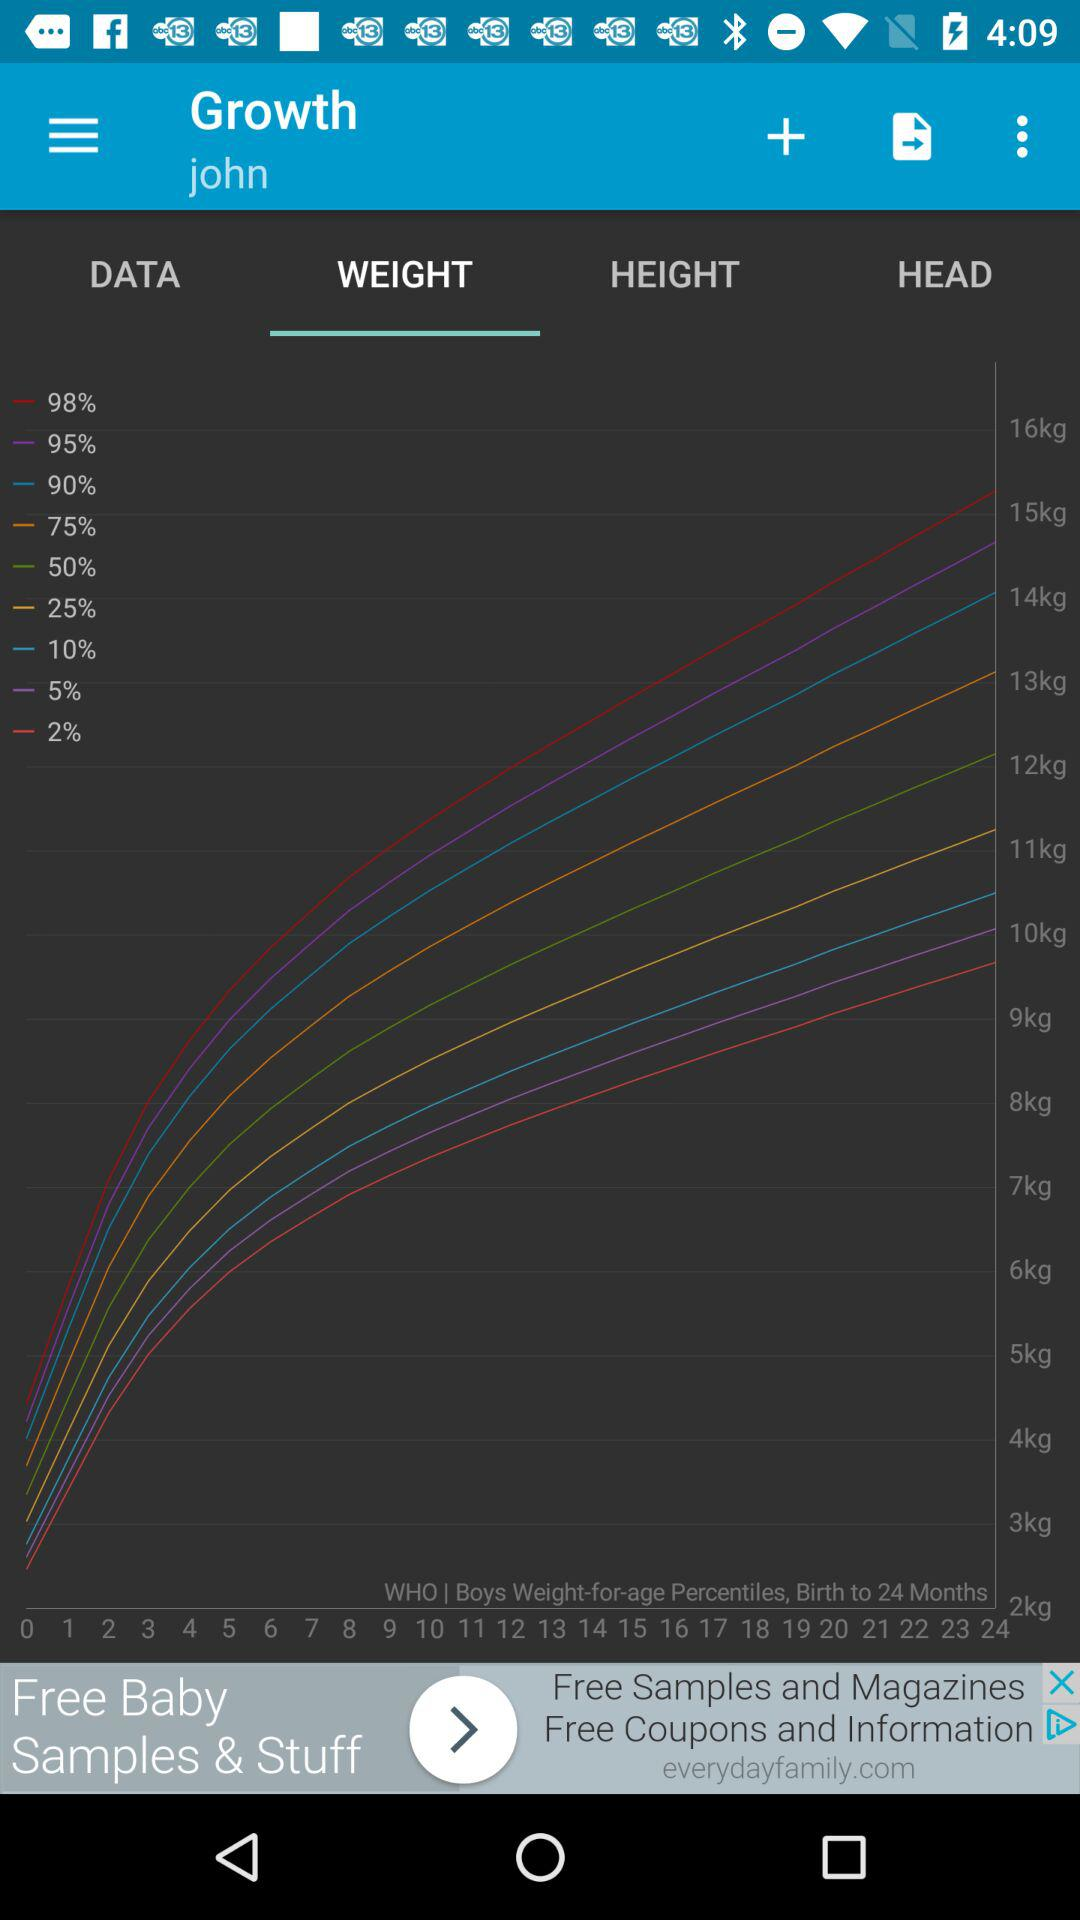What is the name of the user? The name of the user is John. 